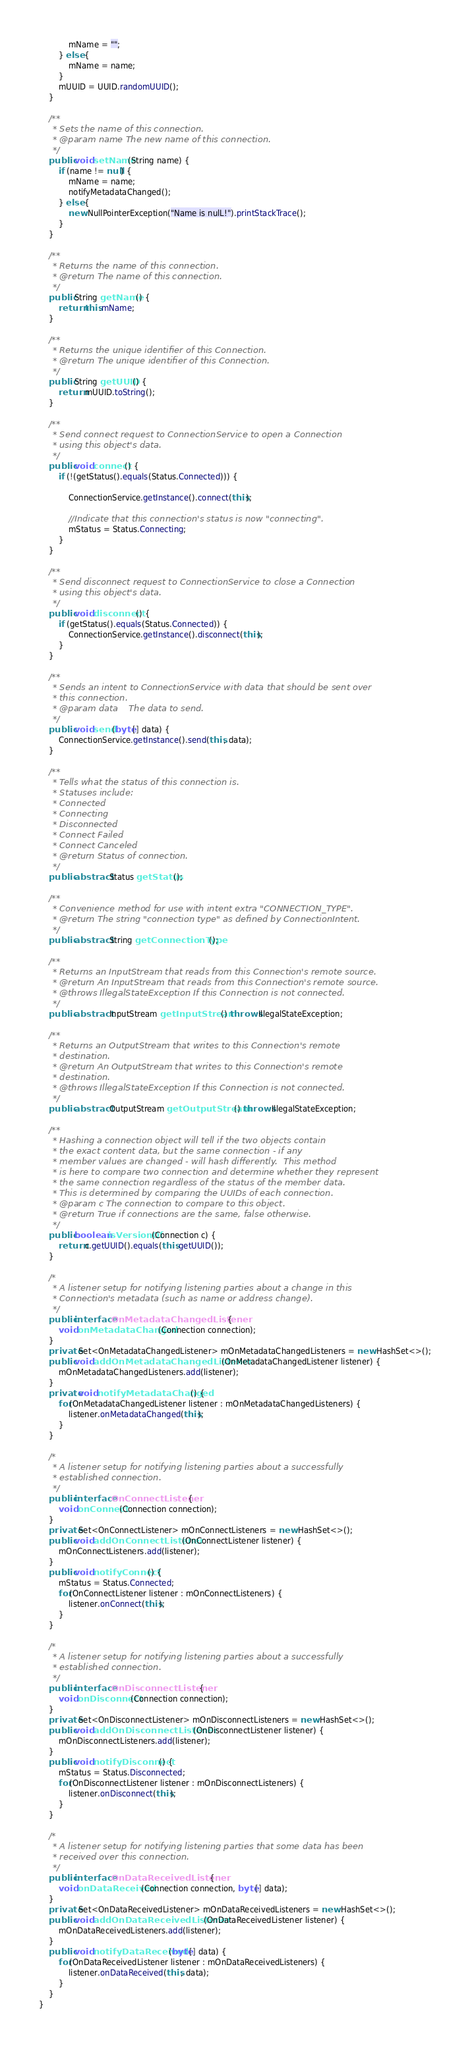<code> <loc_0><loc_0><loc_500><loc_500><_Java_>            mName = "";
        } else {
            mName = name;
        }
        mUUID = UUID.randomUUID();
    }

    /**
     * Sets the name of this connection.
     * @param name The new name of this connection.
     */
    public void setName(String name) {
        if (name != null) {
            mName = name;
            notifyMetadataChanged();
        } else {
            new NullPointerException("Name is nulL!").printStackTrace();
        }
    }

    /**
     * Returns the name of this connection.
     * @return The name of this connection.
     */
    public String getName() {
        return this.mName;
    }

    /**
     * Returns the unique identifier of this Connection.
     * @return The unique identifier of this Connection.
     */
    public String getUUID() {
        return mUUID.toString();
    }

    /**
     * Send connect request to ConnectionService to open a Connection
     * using this object's data.
     */
    public void connect() {
        if (!(getStatus().equals(Status.Connected))) {

            ConnectionService.getInstance().connect(this);

            //Indicate that this connection's status is now "connecting".
            mStatus = Status.Connecting;
        }
    }

    /**
     * Send disconnect request to ConnectionService to close a Connection
     * using this object's data.
     */
    public void disconnect() {
        if (getStatus().equals(Status.Connected)) {
            ConnectionService.getInstance().disconnect(this);
        }
    }

    /**
     * Sends an intent to ConnectionService with data that should be sent over
     * this connection.
     * @param data    The data to send.
     */
    public void send(byte[] data) {
        ConnectionService.getInstance().send(this, data);
    }

    /**
     * Tells what the status of this connection is.
     * Statuses include:
     * Connected
     * Connecting
     * Disconnected
     * Connect Failed
     * Connect Canceled
     * @return Status of connection.
     */
    public abstract Status getStatus();

    /**
     * Convenience method for use with intent extra "CONNECTION_TYPE".
     * @return The string "connection type" as defined by ConnectionIntent.
     */
    public abstract String getConnectionType();

    /**
     * Returns an InputStream that reads from this Connection's remote source.
     * @return An InputStream that reads from this Connection's remote source.
     * @throws IllegalStateException If this Connection is not connected.
     */
    public abstract InputStream getInputStream() throws IllegalStateException;

    /**
     * Returns an OutputStream that writes to this Connection's remote
     * destination.
     * @return An OutputStream that writes to this Connection's remote
     * destination.
     * @throws IllegalStateException If this Connection is not connected.
     */
    public abstract OutputStream getOutputStream() throws IllegalStateException;

    /**
     * Hashing a connection object will tell if the two objects contain
     * the exact content data, but the same connection - if any
     * member values are changed - will hash differently.  This method
     * is here to compare two connection and determine whether they represent
     * the same connection regardless of the status of the member data.
     * This is determined by comparing the UUIDs of each connection.
     * @param c The connection to compare to this object.
     * @return True if connections are the same, false otherwise.
     */
    public boolean isVersionOf(Connection c) {
        return c.getUUID().equals(this.getUUID());
    }

    /*
     * A listener setup for notifying listening parties about a change in this
     * Connection's metadata (such as name or address change).
     */
    public interface OnMetadataChangedListener {
        void onMetadataChanged(Connection connection);
    }
    private Set<OnMetadataChangedListener> mOnMetadataChangedListeners = new HashSet<>();
    public void addOnMetadataChangedListener(OnMetadataChangedListener listener) {
        mOnMetadataChangedListeners.add(listener);
    }
    private void notifyMetadataChanged() {
        for(OnMetadataChangedListener listener : mOnMetadataChangedListeners) {
            listener.onMetadataChanged(this);
        }
    }

    /*
     * A listener setup for notifying listening parties about a successfully
     * established connection.
     */
    public interface OnConnectListener {
        void onConnect(Connection connection);
    }
    private Set<OnConnectListener> mOnConnectListeners = new HashSet<>();
    public void addOnConnectListener(OnConnectListener listener) {
        mOnConnectListeners.add(listener);
    }
    public void notifyConnect() {
        mStatus = Status.Connected;
        for(OnConnectListener listener : mOnConnectListeners) {
            listener.onConnect(this);
        }
    }

    /*
     * A listener setup for notifying listening parties about a successfully
     * established connection.
     */
    public interface OnDisconnectListener {
        void onDisconnect(Connection connection);
    }
    private Set<OnDisconnectListener> mOnDisconnectListeners = new HashSet<>();
    public void addOnDisconnectListener(OnDisconnectListener listener) {
        mOnDisconnectListeners.add(listener);
    }
    public void notifyDisconnect() {
        mStatus = Status.Disconnected;
        for(OnDisconnectListener listener : mOnDisconnectListeners) {
            listener.onDisconnect(this);
        }
    }

    /*
     * A listener setup for notifying listening parties that some data has been
     * received over this connection.
     */
    public interface OnDataReceivedListener {
        void onDataReceived(Connection connection, byte[] data);
    }
    private Set<OnDataReceivedListener> mOnDataReceivedListeners = new HashSet<>();
    public void addOnDataReceivedListener(OnDataReceivedListener listener) {
        mOnDataReceivedListeners.add(listener);
    }
    public void notifyDataReceived(byte[] data) {
        for(OnDataReceivedListener listener : mOnDataReceivedListeners) {
            listener.onDataReceived(this, data);
        }
    }
}</code> 